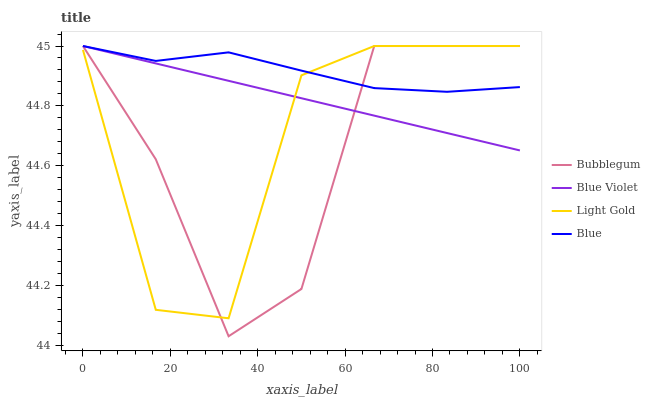Does Bubblegum have the minimum area under the curve?
Answer yes or no. Yes. Does Blue have the maximum area under the curve?
Answer yes or no. Yes. Does Light Gold have the minimum area under the curve?
Answer yes or no. No. Does Light Gold have the maximum area under the curve?
Answer yes or no. No. Is Blue Violet the smoothest?
Answer yes or no. Yes. Is Light Gold the roughest?
Answer yes or no. Yes. Is Light Gold the smoothest?
Answer yes or no. No. Is Blue Violet the roughest?
Answer yes or no. No. Does Bubblegum have the lowest value?
Answer yes or no. Yes. Does Light Gold have the lowest value?
Answer yes or no. No. Does Bubblegum have the highest value?
Answer yes or no. Yes. Does Bubblegum intersect Light Gold?
Answer yes or no. Yes. Is Bubblegum less than Light Gold?
Answer yes or no. No. Is Bubblegum greater than Light Gold?
Answer yes or no. No. 